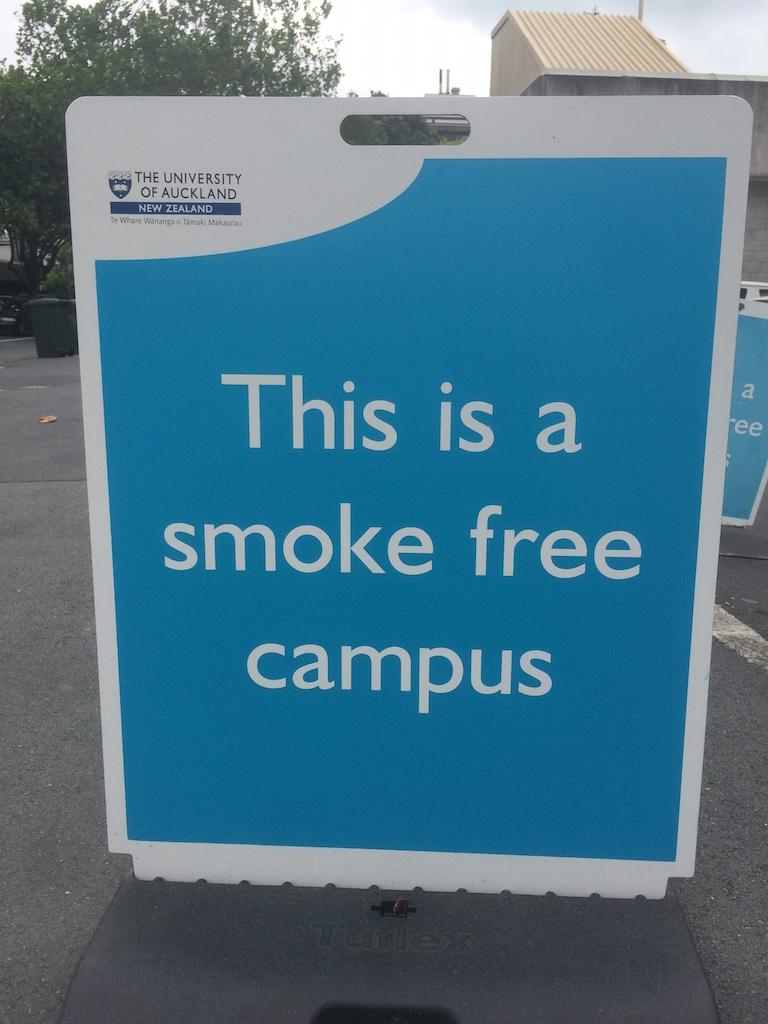Provide a one-sentence caption for the provided image. A sign that says"this is a smoke free campus.". 